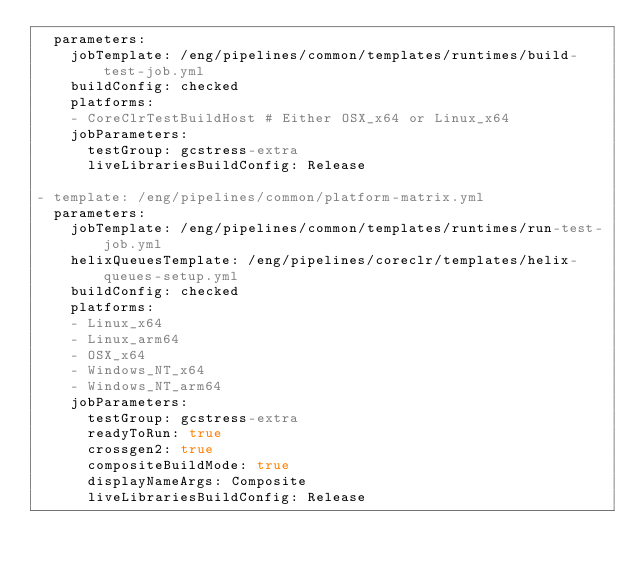<code> <loc_0><loc_0><loc_500><loc_500><_YAML_>  parameters:
    jobTemplate: /eng/pipelines/common/templates/runtimes/build-test-job.yml
    buildConfig: checked
    platforms:
    - CoreClrTestBuildHost # Either OSX_x64 or Linux_x64
    jobParameters:
      testGroup: gcstress-extra
      liveLibrariesBuildConfig: Release

- template: /eng/pipelines/common/platform-matrix.yml
  parameters:
    jobTemplate: /eng/pipelines/common/templates/runtimes/run-test-job.yml
    helixQueuesTemplate: /eng/pipelines/coreclr/templates/helix-queues-setup.yml
    buildConfig: checked
    platforms:
    - Linux_x64
    - Linux_arm64
    - OSX_x64
    - Windows_NT_x64
    - Windows_NT_arm64
    jobParameters:
      testGroup: gcstress-extra
      readyToRun: true
      crossgen2: true
      compositeBuildMode: true
      displayNameArgs: Composite
      liveLibrariesBuildConfig: Release
</code> 